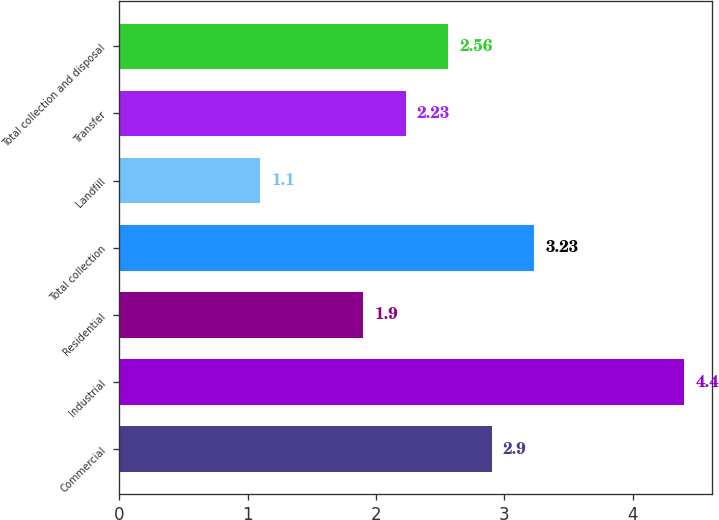Convert chart to OTSL. <chart><loc_0><loc_0><loc_500><loc_500><bar_chart><fcel>Commercial<fcel>Industrial<fcel>Residential<fcel>Total collection<fcel>Landfill<fcel>Transfer<fcel>Total collection and disposal<nl><fcel>2.9<fcel>4.4<fcel>1.9<fcel>3.23<fcel>1.1<fcel>2.23<fcel>2.56<nl></chart> 